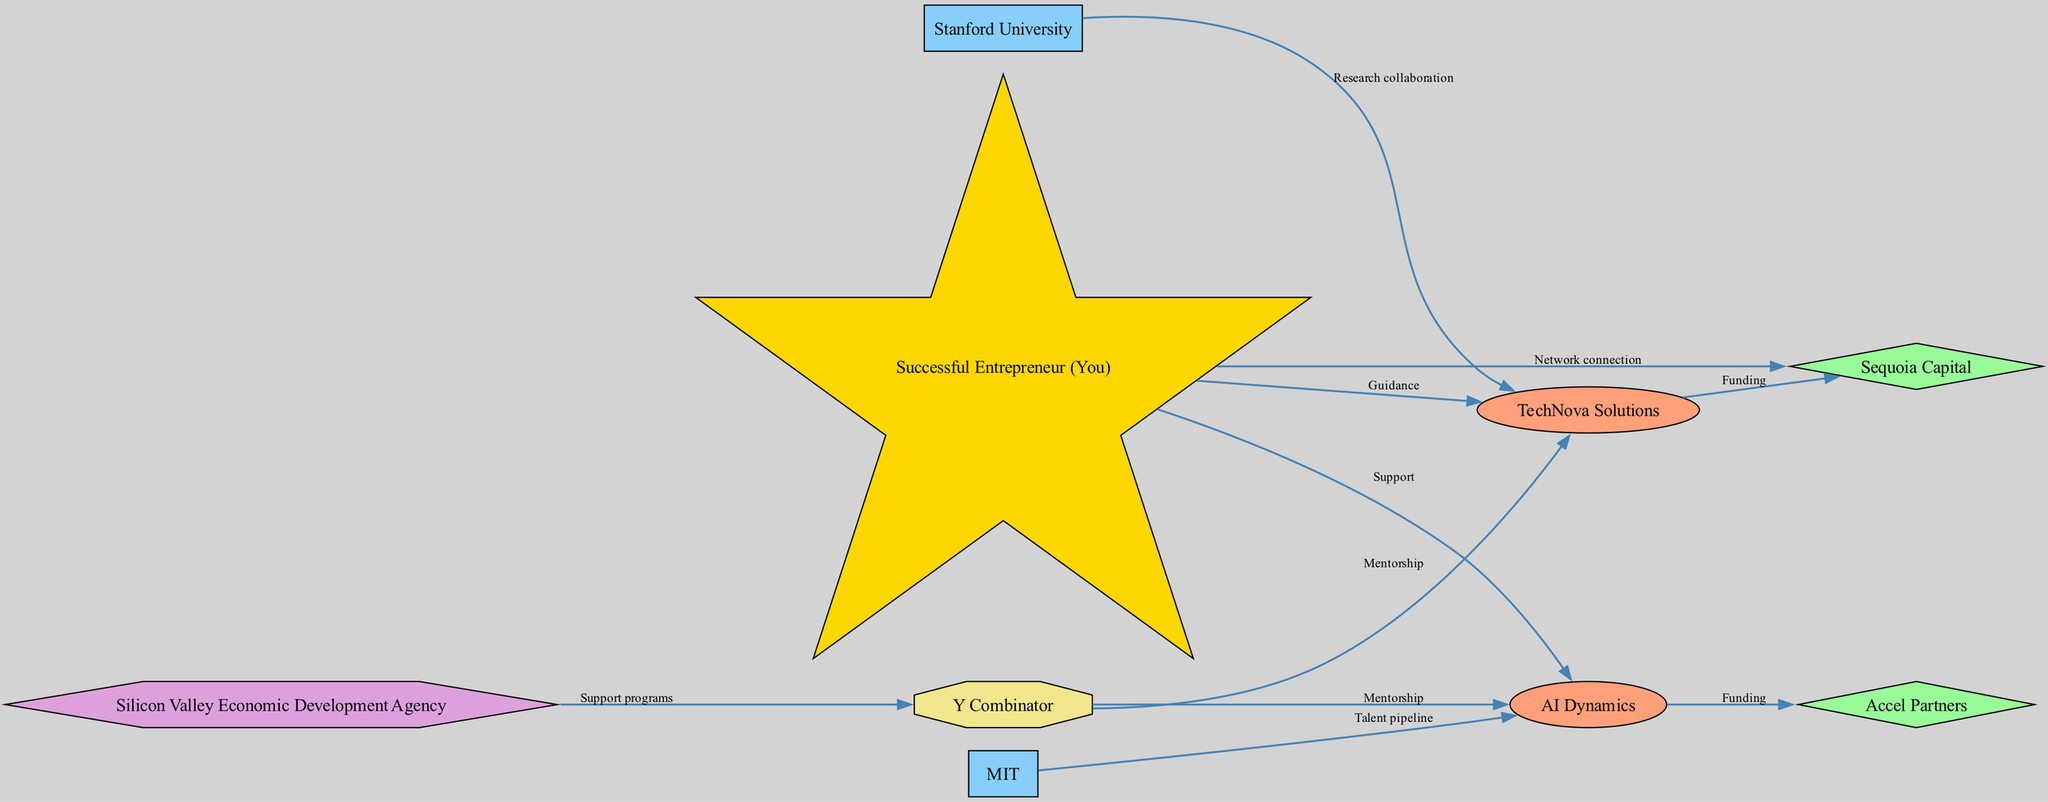What are the types of nodes shown in the diagram? The diagram presents several types of nodes including Startups, Investors, Universities, Government Agencies, Incubators, and Mentors. These can be identified by the unique shapes and colors associated with each type.
Answer: Startups, Investors, Universities, Government Agencies, Incubators, Mentors How many startups are listed in the diagram? By examining the nodes in the diagram, I can count two startups: TechNova Solutions and AI Dynamics. This is straightforward as each startup node is labeled clearly.
Answer: 2 Which startup is connected to Sequoia Capital? The diagram specifies that TechNova Solutions is the startup that has a funding relationship with Sequoia Capital, as indicated by the edge labeled "Funding."
Answer: TechNova Solutions What type of relationship exists between MIT and AI Dynamics? The edge from MIT to AI Dynamics is labeled "Talent pipeline," indicating that this is the type of support or relationship between these two nodes.
Answer: Talent pipeline Which incubator receives support from the government agency? According to the diagram, Y Combinator is the incubator that receives support from the Silicon Valley Economic Development Agency. This is identified by the edge labeled "Support programs."
Answer: Y Combinator How many edges connect startups to investors? The diagram shows two edges connecting startups to investors. Each startup has one connection to a different investor, demonstrating the investment relationships.
Answer: 2 Which node type has a mentorship connection with both startups? The incubator, Y Combinator, is the node type that has mentorship connections to both TechNova Solutions and AI Dynamics. This represents its role in supporting multiple startups.
Answer: Incubator How many distinct government agencies are present in the diagram? The diagram shows one government agency, which is the Silicon Valley Economic Development Agency; this can be identified clearly as it's the only node of its type.
Answer: 1 What is the primary purpose of the connection from the successful entrepreneur to the startups? The connections from the successful entrepreneur node to both startups are labeled as "Guidance" and "Support," indicating the primary role is to provide mentorship and advice.
Answer: Guidance and Support 